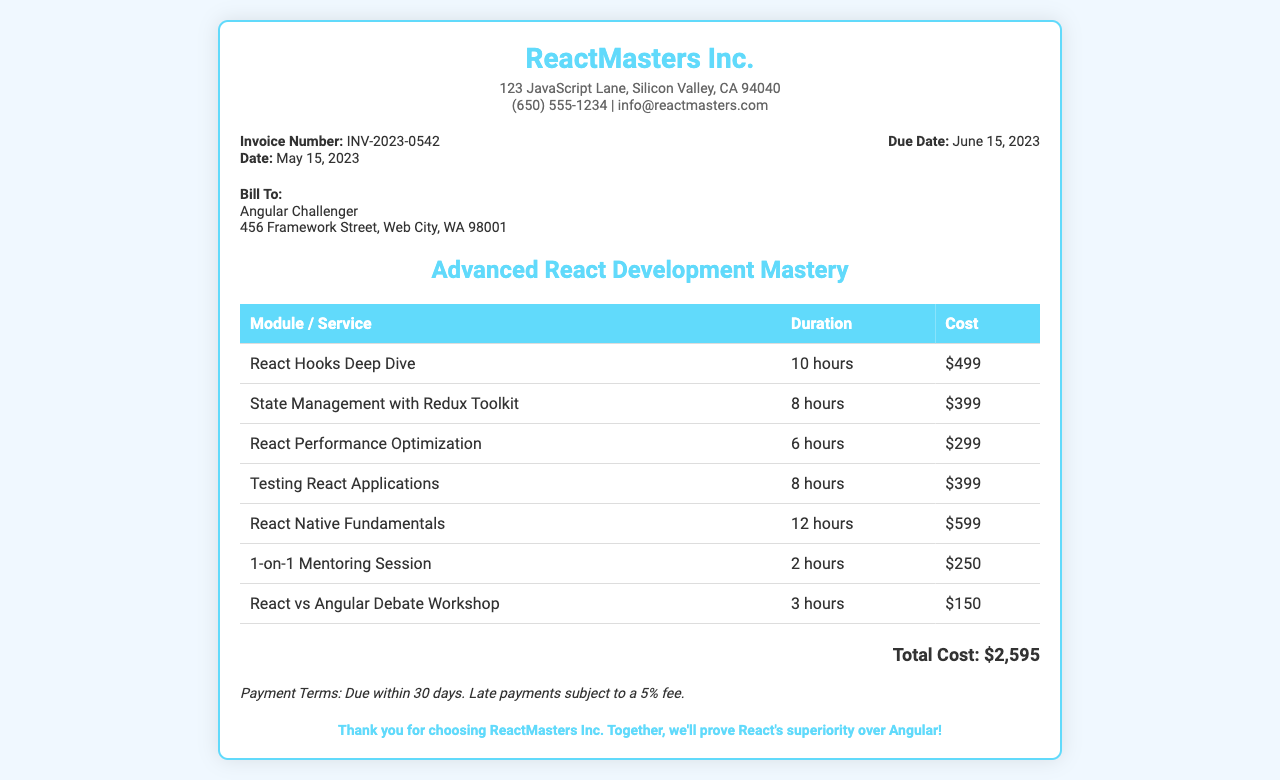What is the invoice number? The invoice number is stated as INV-2023-0542 in the document.
Answer: INV-2023-0542 What is the due date for the invoice? The due date is mentioned as June 15, 2023 in the invoice details.
Answer: June 15, 2023 How much is the cost for the "React Native Fundamentals" module? The document lists the cost for this module as $599.
Answer: $599 How many hours is the "Testing React Applications" module? The duration for this module is mentioned as 8 hours in the table.
Answer: 8 hours What is the total cost of the course? The total cost is calculated and presented as $2,595 at the end of the document.
Answer: $2,595 What is the payment term specified in the invoice? The payment term is stated as due within 30 days with a late fee mentioned as 5%.
Answer: Due within 30 days Who is billed in this invoice? The document indicates that the bill is directed to Angular Challenger.
Answer: Angular Challenger What is the duration of the "1-on-1 Mentoring Session"? The mentioned duration for this session is 2 hours in the breakdown.
Answer: 2 hours What company issued this invoice? The company issuing the invoice is ReactMasters Inc., as stated at the top.
Answer: ReactMasters Inc 